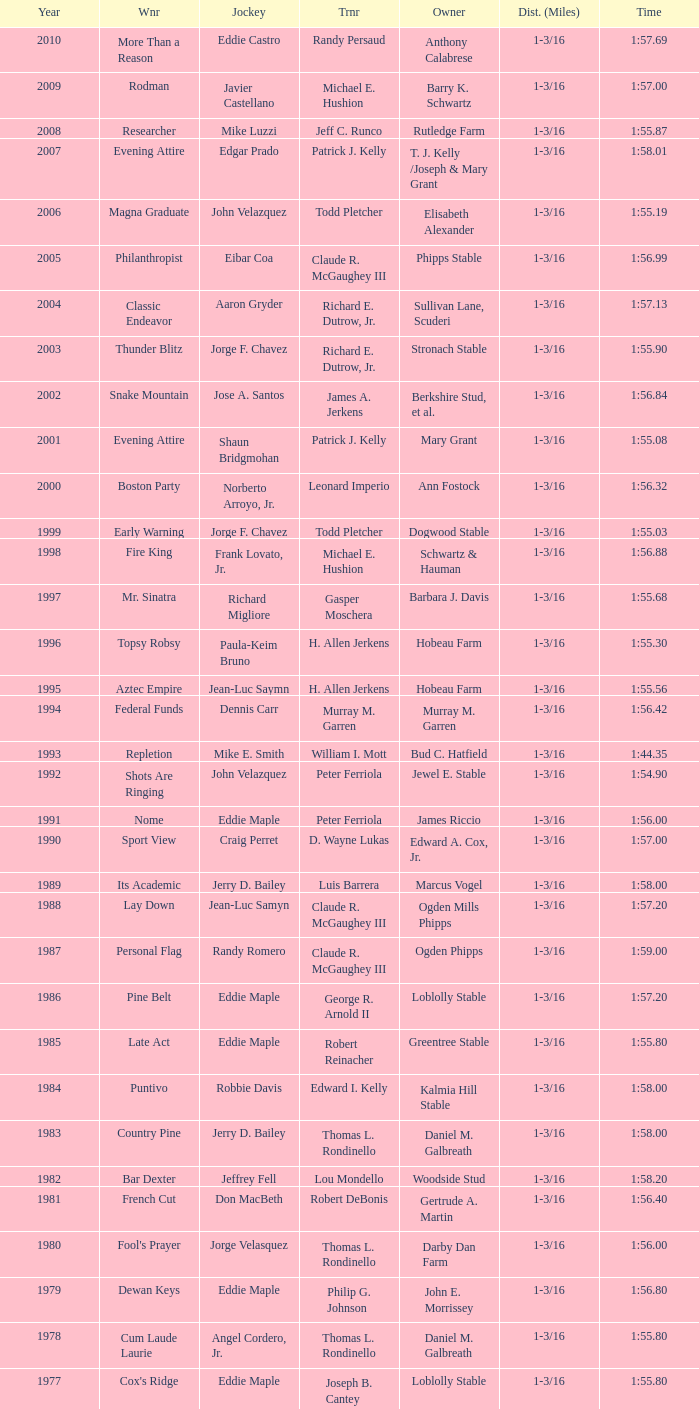I'm looking to parse the entire table for insights. Could you assist me with that? {'header': ['Year', 'Wnr', 'Jockey', 'Trnr', 'Owner', 'Dist. (Miles)', 'Time'], 'rows': [['2010', 'More Than a Reason', 'Eddie Castro', 'Randy Persaud', 'Anthony Calabrese', '1-3/16', '1:57.69'], ['2009', 'Rodman', 'Javier Castellano', 'Michael E. Hushion', 'Barry K. Schwartz', '1-3/16', '1:57.00'], ['2008', 'Researcher', 'Mike Luzzi', 'Jeff C. Runco', 'Rutledge Farm', '1-3/16', '1:55.87'], ['2007', 'Evening Attire', 'Edgar Prado', 'Patrick J. Kelly', 'T. J. Kelly /Joseph & Mary Grant', '1-3/16', '1:58.01'], ['2006', 'Magna Graduate', 'John Velazquez', 'Todd Pletcher', 'Elisabeth Alexander', '1-3/16', '1:55.19'], ['2005', 'Philanthropist', 'Eibar Coa', 'Claude R. McGaughey III', 'Phipps Stable', '1-3/16', '1:56.99'], ['2004', 'Classic Endeavor', 'Aaron Gryder', 'Richard E. Dutrow, Jr.', 'Sullivan Lane, Scuderi', '1-3/16', '1:57.13'], ['2003', 'Thunder Blitz', 'Jorge F. Chavez', 'Richard E. Dutrow, Jr.', 'Stronach Stable', '1-3/16', '1:55.90'], ['2002', 'Snake Mountain', 'Jose A. Santos', 'James A. Jerkens', 'Berkshire Stud, et al.', '1-3/16', '1:56.84'], ['2001', 'Evening Attire', 'Shaun Bridgmohan', 'Patrick J. Kelly', 'Mary Grant', '1-3/16', '1:55.08'], ['2000', 'Boston Party', 'Norberto Arroyo, Jr.', 'Leonard Imperio', 'Ann Fostock', '1-3/16', '1:56.32'], ['1999', 'Early Warning', 'Jorge F. Chavez', 'Todd Pletcher', 'Dogwood Stable', '1-3/16', '1:55.03'], ['1998', 'Fire King', 'Frank Lovato, Jr.', 'Michael E. Hushion', 'Schwartz & Hauman', '1-3/16', '1:56.88'], ['1997', 'Mr. Sinatra', 'Richard Migliore', 'Gasper Moschera', 'Barbara J. Davis', '1-3/16', '1:55.68'], ['1996', 'Topsy Robsy', 'Paula-Keim Bruno', 'H. Allen Jerkens', 'Hobeau Farm', '1-3/16', '1:55.30'], ['1995', 'Aztec Empire', 'Jean-Luc Saymn', 'H. Allen Jerkens', 'Hobeau Farm', '1-3/16', '1:55.56'], ['1994', 'Federal Funds', 'Dennis Carr', 'Murray M. Garren', 'Murray M. Garren', '1-3/16', '1:56.42'], ['1993', 'Repletion', 'Mike E. Smith', 'William I. Mott', 'Bud C. Hatfield', '1-3/16', '1:44.35'], ['1992', 'Shots Are Ringing', 'John Velazquez', 'Peter Ferriola', 'Jewel E. Stable', '1-3/16', '1:54.90'], ['1991', 'Nome', 'Eddie Maple', 'Peter Ferriola', 'James Riccio', '1-3/16', '1:56.00'], ['1990', 'Sport View', 'Craig Perret', 'D. Wayne Lukas', 'Edward A. Cox, Jr.', '1-3/16', '1:57.00'], ['1989', 'Its Academic', 'Jerry D. Bailey', 'Luis Barrera', 'Marcus Vogel', '1-3/16', '1:58.00'], ['1988', 'Lay Down', 'Jean-Luc Samyn', 'Claude R. McGaughey III', 'Ogden Mills Phipps', '1-3/16', '1:57.20'], ['1987', 'Personal Flag', 'Randy Romero', 'Claude R. McGaughey III', 'Ogden Phipps', '1-3/16', '1:59.00'], ['1986', 'Pine Belt', 'Eddie Maple', 'George R. Arnold II', 'Loblolly Stable', '1-3/16', '1:57.20'], ['1985', 'Late Act', 'Eddie Maple', 'Robert Reinacher', 'Greentree Stable', '1-3/16', '1:55.80'], ['1984', 'Puntivo', 'Robbie Davis', 'Edward I. Kelly', 'Kalmia Hill Stable', '1-3/16', '1:58.00'], ['1983', 'Country Pine', 'Jerry D. Bailey', 'Thomas L. Rondinello', 'Daniel M. Galbreath', '1-3/16', '1:58.00'], ['1982', 'Bar Dexter', 'Jeffrey Fell', 'Lou Mondello', 'Woodside Stud', '1-3/16', '1:58.20'], ['1981', 'French Cut', 'Don MacBeth', 'Robert DeBonis', 'Gertrude A. Martin', '1-3/16', '1:56.40'], ['1980', "Fool's Prayer", 'Jorge Velasquez', 'Thomas L. Rondinello', 'Darby Dan Farm', '1-3/16', '1:56.00'], ['1979', 'Dewan Keys', 'Eddie Maple', 'Philip G. Johnson', 'John E. Morrissey', '1-3/16', '1:56.80'], ['1978', 'Cum Laude Laurie', 'Angel Cordero, Jr.', 'Thomas L. Rondinello', 'Daniel M. Galbreath', '1-3/16', '1:55.80'], ['1977', "Cox's Ridge", 'Eddie Maple', 'Joseph B. Cantey', 'Loblolly Stable', '1-3/16', '1:55.80'], ['1976', "It's Freezing", 'Jacinto Vasquez', 'Anthony Basile', 'Bwamazon Farm', '1-3/16', '1:56.60'], ['1975', 'Hail The Pirates', 'Ron Turcotte', 'Thomas L. Rondinello', 'Daniel M. Galbreath', '1-3/16', '1:55.60'], ['1974', 'Free Hand', 'Jose Amy', 'Pancho Martin', 'Sigmund Sommer', '1-3/16', '1:55.00'], ['1973', 'True Knight', 'Angel Cordero, Jr.', 'Thomas L. Rondinello', 'Darby Dan Farm', '1-3/16', '1:55.00'], ['1972', 'Sunny And Mild', 'Michael Venezia', 'W. Preston King', 'Harry Rogosin', '1-3/16', '1:54.40'], ['1971', 'Red Reality', 'Jorge Velasquez', 'MacKenzie Miller', 'Cragwood Stables', '1-1/8', '1:49.60'], ['1970', 'Best Turn', 'Larry Adams', 'Reggie Cornell', 'Calumet Farm', '1-1/8', '1:50.00'], ['1969', 'Vif', 'Larry Adams', 'Clarence Meaux', 'Harvey Peltier', '1-1/8', '1:49.20'], ['1968', 'Irish Dude', 'Sandino Hernandez', 'Jack Bradley', 'Richard W. Taylor', '1-1/8', '1:49.60'], ['1967', 'Mr. Right', 'Heliodoro Gustines', 'Evan S. Jackson', 'Mrs. Peter Duchin', '1-1/8', '1:49.60'], ['1966', 'Amberoid', 'Walter Blum', 'Lucien Laurin', 'Reginald N. Webster', '1-1/8', '1:50.60'], ['1965', 'Prairie Schooner', 'Eddie Belmonte', 'James W. Smith', 'High Tide Stable', '1-1/8', '1:50.20'], ['1964', 'Third Martini', 'William Boland', 'H. Allen Jerkens', 'Hobeau Farm', '1-1/8', '1:50.60'], ['1963', 'Uppercut', 'Manuel Ycaza', 'Willard C. Freeman', 'William Harmonay', '1-1/8', '1:35.40'], ['1962', 'Grid Iron Hero', 'Manuel Ycaza', 'Laz Barrera', 'Emil Dolce', '1 mile', '1:34.00'], ['1961', 'Manassa Mauler', 'Braulio Baeza', 'Pancho Martin', 'Emil Dolce', '1 mile', '1:36.20'], ['1960', 'Cranberry Sauce', 'Heliodoro Gustines', 'not found', 'Elmendorf Farm', '1 mile', '1:36.20'], ['1959', 'Whitley', 'Eric Guerin', 'Max Hirsch', 'W. Arnold Hanger', '1 mile', '1:36.40'], ['1958', 'Oh Johnny', 'William Boland', 'Norman R. McLeod', 'Mrs. Wallace Gilroy', '1-1/16', '1:43.40'], ['1957', 'Bold Ruler', 'Eddie Arcaro', 'James E. Fitzsimmons', 'Wheatley Stable', '1-1/16', '1:42.80'], ['1956', 'Blessbull', 'Willie Lester', 'not found', 'Morris Sims', '1-1/16', '1:42.00'], ['1955', 'Fabulist', 'Ted Atkinson', 'William C. Winfrey', 'High Tide Stable', '1-1/16', '1:43.60'], ['1954', 'Find', 'Eric Guerin', 'William C. Winfrey', 'Alfred G. Vanderbilt II', '1-1/16', '1:44.00'], ['1953', 'Flaunt', 'S. Cole', 'Hubert W. Williams', 'Arnold Skjeveland', '1-1/16', '1:44.20'], ['1952', 'County Delight', 'Dave Gorman', 'James E. Ryan', 'Rokeby Stable', '1-1/16', '1:43.60'], ['1951', 'Sheilas Reward', 'Ovie Scurlock', 'Eugene Jacobs', 'Mrs. Louis Lazare', '1-1/16', '1:44.60'], ['1950', 'Three Rings', 'Hedley Woodhouse', 'Willie Knapp', 'Mrs. Evelyn L. Hopkins', '1-1/16', '1:44.60'], ['1949', 'Three Rings', 'Ted Atkinson', 'Willie Knapp', 'Mrs. Evelyn L. Hopkins', '1-1/16', '1:47.40'], ['1948', 'Knockdown', 'Ferrill Zufelt', 'Tom Smith', 'Maine Chance Farm', '1-1/16', '1:44.60'], ['1947', 'Gallorette', 'Job Dean Jessop', 'Edward A. Christmas', 'William L. Brann', '1-1/16', '1:45.40'], ['1946', 'Helioptic', 'Paul Miller', 'not found', 'William Goadby Loew', '1-1/16', '1:43.20'], ['1945', 'Olympic Zenith', 'Conn McCreary', 'Willie Booth', 'William G. Helis', '1-1/16', '1:45.60'], ['1944', 'First Fiddle', 'Johnny Longden', 'Edward Mulrenan', 'Mrs. Edward Mulrenan', '1-1/16', '1:44.20'], ['1943', 'The Rhymer', 'Conn McCreary', 'John M. Gaver, Sr.', 'Greentree Stable', '1-1/16', '1:45.00'], ['1942', 'Waller', 'Billie Thompson', 'A. G. Robertson', 'John C. Clark', '1-1/16', '1:44.00'], ['1941', 'Salford II', 'Don Meade', 'not found', 'Ralph B. Strassburger', '1-1/16', '1:44.20'], ['1940', 'He Did', 'Eddie Arcaro', 'J. Thomas Taylor', 'W. Arnold Hanger', '1-1/16', '1:43.20'], ['1939', 'Lovely Night', 'Johnny Longden', 'Henry McDaniel', 'Mrs. F. Ambrose Clark', '1 mile', '1:36.40'], ['1938', 'War Admiral', 'Charles Kurtsinger', 'George Conway', 'Glen Riddle Farm', '1 mile', '1:36.80'], ['1937', 'Snark', 'Johnny Longden', 'James E. Fitzsimmons', 'Wheatley Stable', '1 mile', '1:37.40'], ['1936', 'Good Gamble', 'Samuel Renick', 'Bud Stotler', 'Alfred G. Vanderbilt II', '1 mile', '1:37.20'], ['1935', 'King Saxon', 'Calvin Rainey', 'Charles Shaw', 'C. H. Knebelkamp', '1 mile', '1:37.20'], ['1934', 'Singing Wood', 'Robert Jones', 'James W. Healy', 'Liz Whitney', '1 mile', '1:38.60'], ['1933', 'Kerry Patch', 'Robert Wholey', 'Joseph A. Notter', 'Lee Rosenberg', '1 mile', '1:38.00'], ['1932', 'Halcyon', 'Hank Mills', 'T. J. Healey', 'C. V. Whitney', '1 mile', '1:38.00'], ['1931', 'Halcyon', 'G. Rose', 'T. J. Healey', 'C. V. Whitney', '1 mile', '1:38.40'], ['1930', 'Kildare', 'John Passero', 'Norman Tallman', 'Newtondale Stable', '1 mile', '1:38.60'], ['1929', 'Comstockery', 'Sidney Hebert', 'Thomas W. Murphy', 'Greentree Stable', '1 mile', '1:39.60'], ['1928', 'Kentucky II', 'George Schreiner', 'Max Hirsch', 'A. Charles Schwartz', '1 mile', '1:38.80'], ['1927', 'Light Carbine', 'James McCoy', 'M. J. Dunlevy', 'I. B. Humphreys', '1 mile', '1:36.80'], ['1926', 'Macaw', 'Linus McAtee', 'James G. Rowe, Sr.', 'Harry Payne Whitney', '1 mile', '1:37.00'], ['1925', 'Mad Play', 'Laverne Fator', 'Sam Hildreth', 'Rancocas Stable', '1 mile', '1:36.60'], ['1924', 'Mad Hatter', 'Earl Sande', 'Sam Hildreth', 'Rancocas Stable', '1 mile', '1:36.60'], ['1923', 'Zev', 'Earl Sande', 'Sam Hildreth', 'Rancocas Stable', '1 mile', '1:37.00'], ['1922', 'Grey Lag', 'Laverne Fator', 'Sam Hildreth', 'Rancocas Stable', '1 mile', '1:38.00'], ['1921', 'John P. Grier', 'Frank Keogh', 'James G. Rowe, Sr.', 'Harry Payne Whitney', '1 mile', '1:36.00'], ['1920', 'Cirrus', 'Lavelle Ensor', 'Sam Hildreth', 'Sam Hildreth', '1 mile', '1:38.00'], ['1919', 'Star Master', 'Merritt Buxton', 'Walter B. Jennings', 'A. Kingsley Macomber', '1 mile', '1:37.60'], ['1918', 'Roamer', 'Lawrence Lyke', 'A. J. Goldsborough', 'Andrew Miller', '1 mile', '1:36.60'], ['1917', 'Old Rosebud', 'Frank Robinson', 'Frank D. Weir', 'F. D. Weir & Hamilton C. Applegate', '1 mile', '1:37.60'], ['1916', 'Short Grass', 'Frank Keogh', 'not found', 'Emil Herz', '1 mile', '1:36.40'], ['1915', 'Roamer', 'James Butwell', 'A. J. Goldsborough', 'Andrew Miller', '1 mile', '1:39.20'], ['1914', 'Flying Fairy', 'Tommy Davies', 'J. Simon Healy', 'Edward B. Cassatt', '1 mile', '1:42.20'], ['1913', 'No Race', 'No Race', 'No Race', 'No Race', '1 mile', 'no race'], ['1912', 'No Race', 'No Race', 'No Race', 'No Race', '1 mile', 'no race'], ['1911', 'No Race', 'No Race', 'No Race', 'No Race', '1 mile', 'no race'], ['1910', 'Arasee', 'Buddy Glass', 'Andrew G. Blakely', 'Samuel Emery', '1 mile', '1:39.80'], ['1909', 'No Race', 'No Race', 'No Race', 'No Race', '1 mile', 'no race'], ['1908', 'Jack Atkin', 'Phil Musgrave', 'Herman R. Brandt', 'Barney Schreiber', '1 mile', '1:39.00'], ['1907', 'W. H. Carey', 'George Mountain', 'James Blute', 'Richard F. Carman', '1 mile', '1:40.00'], ['1906', "Ram's Horn", 'L. Perrine', 'W. S. "Jim" Williams', 'W. S. "Jim" Williams', '1 mile', '1:39.40'], ['1905', 'St. Valentine', 'William Crimmins', 'John Shields', 'Alexander Shields', '1 mile', '1:39.20'], ['1904', 'Rosetint', 'Thomas H. Burns', 'James Boden', 'John Boden', '1 mile', '1:39.20'], ['1903', 'Yellow Tail', 'Willie Shaw', 'H. E. Rowell', 'John Hackett', '1m 70yds', '1:45.20'], ['1902', 'Margravite', 'Otto Wonderly', 'not found', 'Charles Fleischmann Sons', '1m 70 yds', '1:46.00']]} What was the winning time for the winning horse, Kentucky ii? 1:38.80. 